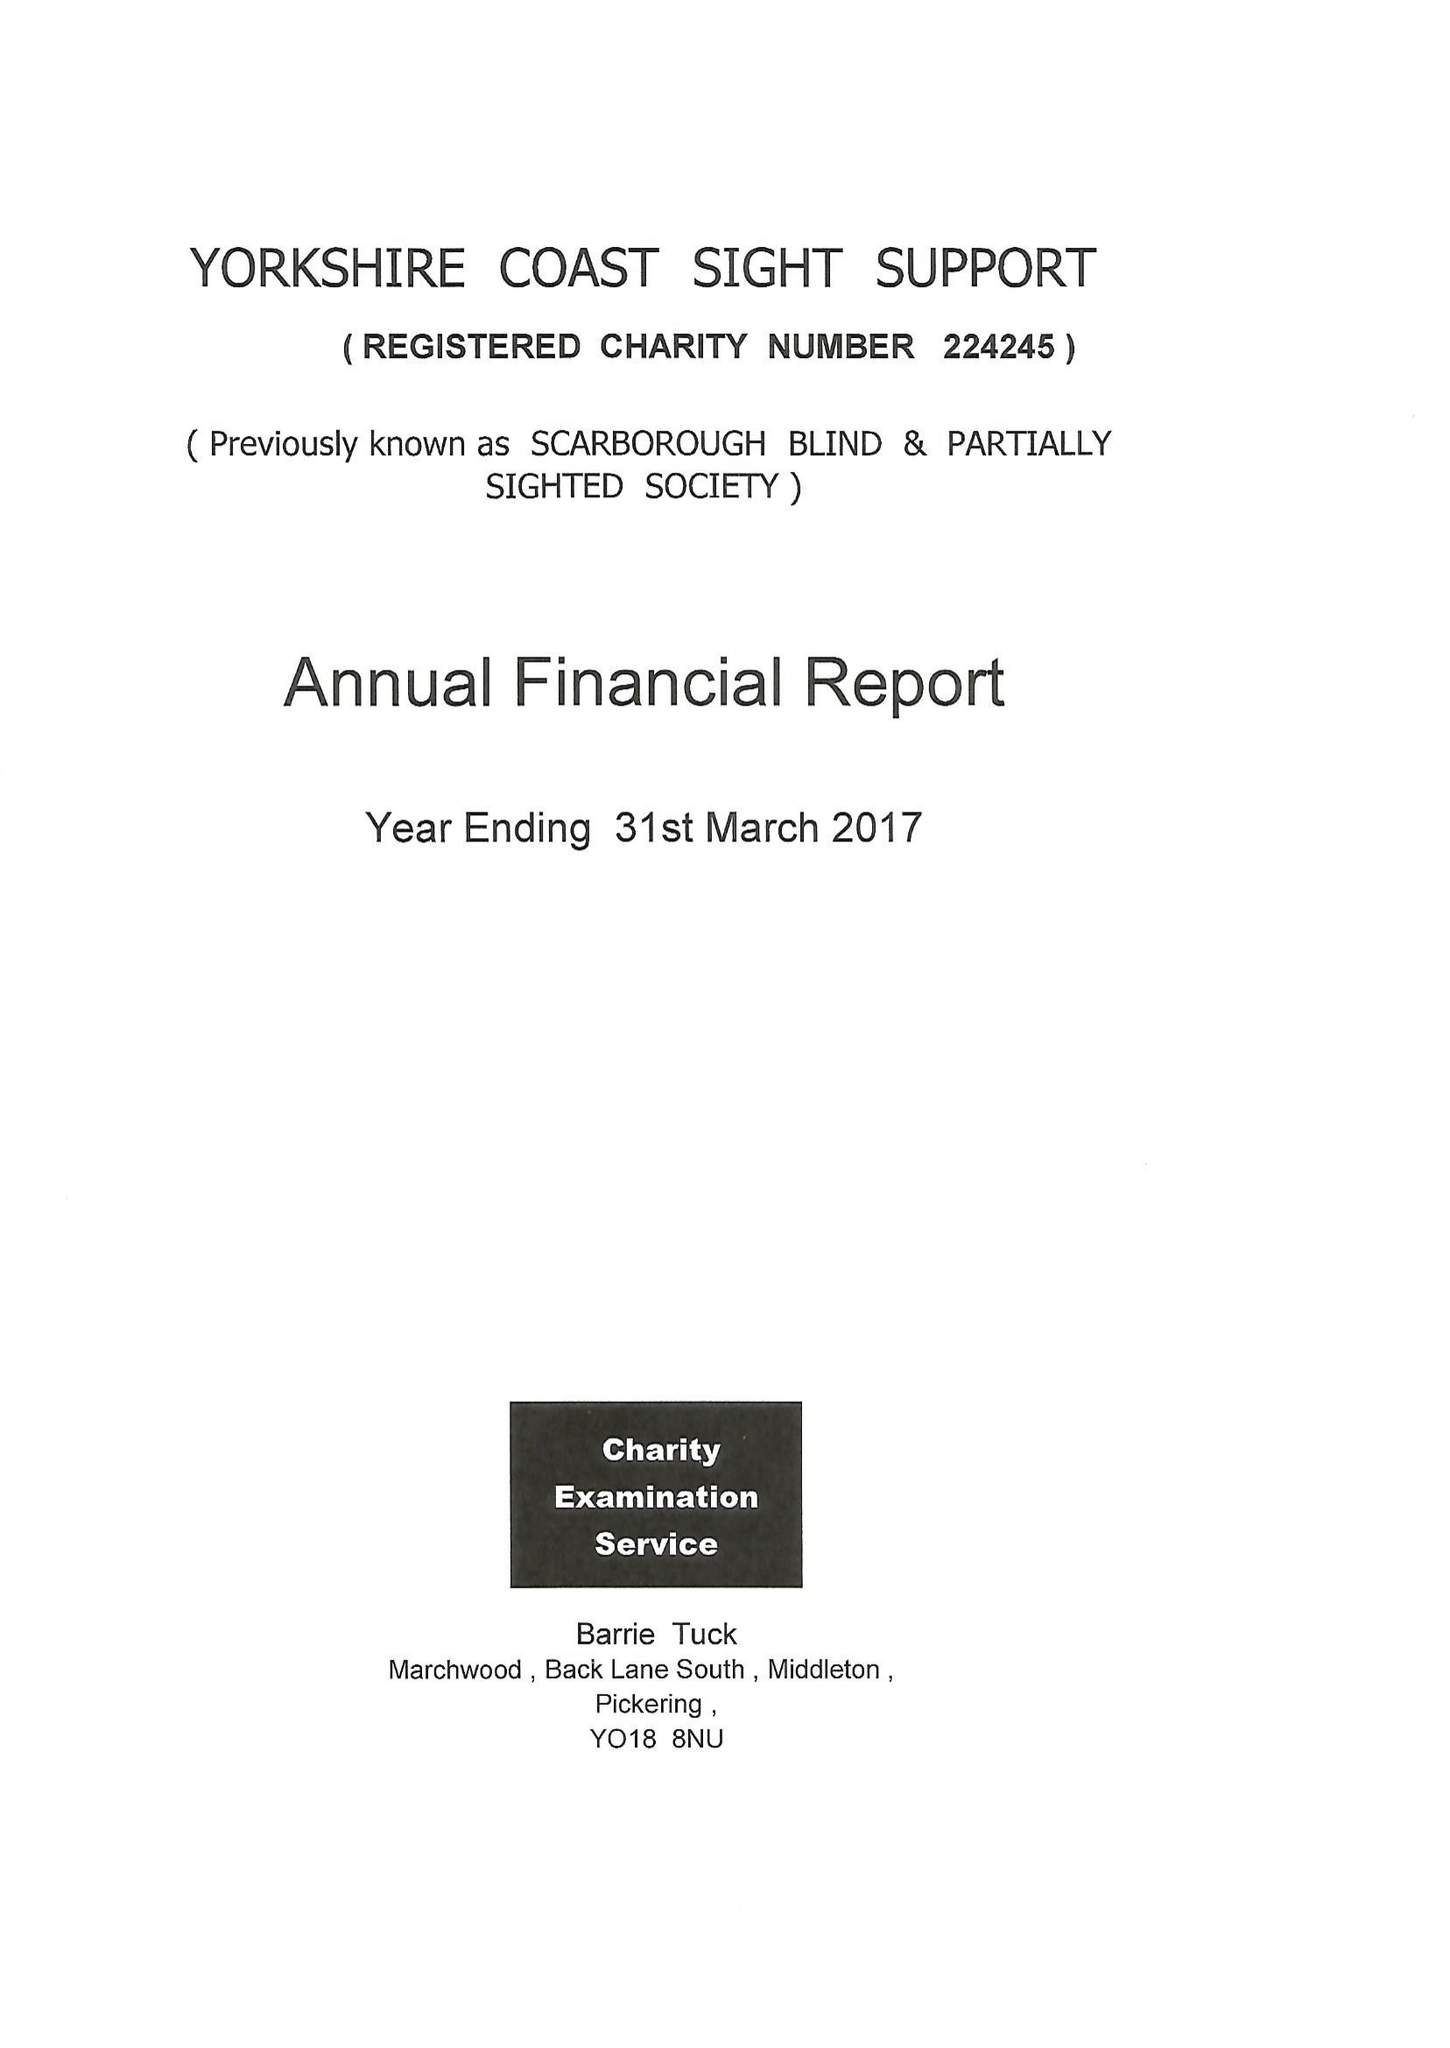What is the value for the income_annually_in_british_pounds?
Answer the question using a single word or phrase. 87784.00 